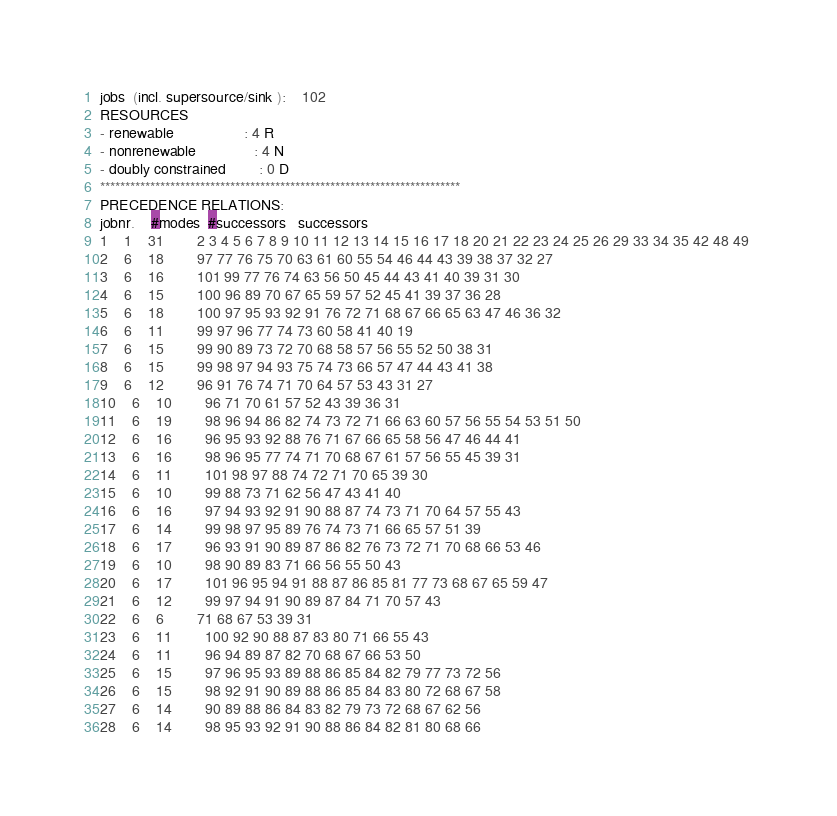<code> <loc_0><loc_0><loc_500><loc_500><_ObjectiveC_>jobs  (incl. supersource/sink ):	102
RESOURCES
- renewable                 : 4 R
- nonrenewable              : 4 N
- doubly constrained        : 0 D
************************************************************************
PRECEDENCE RELATIONS:
jobnr.    #modes  #successors   successors
1	1	31		2 3 4 5 6 7 8 9 10 11 12 13 14 15 16 17 18 20 21 22 23 24 25 26 29 33 34 35 42 48 49 
2	6	18		97 77 76 75 70 63 61 60 55 54 46 44 43 39 38 37 32 27 
3	6	16		101 99 77 76 74 63 56 50 45 44 43 41 40 39 31 30 
4	6	15		100 96 89 70 67 65 59 57 52 45 41 39 37 36 28 
5	6	18		100 97 95 93 92 91 76 72 71 68 67 66 65 63 47 46 36 32 
6	6	11		99 97 96 77 74 73 60 58 41 40 19 
7	6	15		99 90 89 73 72 70 68 58 57 56 55 52 50 38 31 
8	6	15		99 98 97 94 93 75 74 73 66 57 47 44 43 41 38 
9	6	12		96 91 76 74 71 70 64 57 53 43 31 27 
10	6	10		96 71 70 61 57 52 43 39 36 31 
11	6	19		98 96 94 86 82 74 73 72 71 66 63 60 57 56 55 54 53 51 50 
12	6	16		96 95 93 92 88 76 71 67 66 65 58 56 47 46 44 41 
13	6	16		98 96 95 77 74 71 70 68 67 61 57 56 55 45 39 31 
14	6	11		101 98 97 88 74 72 71 70 65 39 30 
15	6	10		99 88 73 71 62 56 47 43 41 40 
16	6	16		97 94 93 92 91 90 88 87 74 73 71 70 64 57 55 43 
17	6	14		99 98 97 95 89 76 74 73 71 66 65 57 51 39 
18	6	17		96 93 91 90 89 87 86 82 76 73 72 71 70 68 66 53 46 
19	6	10		98 90 89 83 71 66 56 55 50 43 
20	6	17		101 96 95 94 91 88 87 86 85 81 77 73 68 67 65 59 47 
21	6	12		99 97 94 91 90 89 87 84 71 70 57 43 
22	6	6		71 68 67 53 39 31 
23	6	11		100 92 90 88 87 83 80 71 66 55 43 
24	6	11		96 94 89 87 82 70 68 67 66 53 50 
25	6	15		97 96 95 93 89 88 86 85 84 82 79 77 73 72 56 
26	6	15		98 92 91 90 89 88 86 85 84 83 80 72 68 67 58 
27	6	14		90 89 88 86 84 83 82 79 73 72 68 67 62 56 
28	6	14		98 95 93 92 91 90 88 86 84 82 81 80 68 66 </code> 